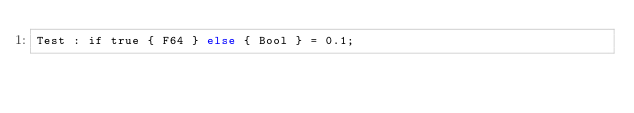<code> <loc_0><loc_0><loc_500><loc_500><_SQL_>Test : if true { F64 } else { Bool } = 0.1;
</code> 